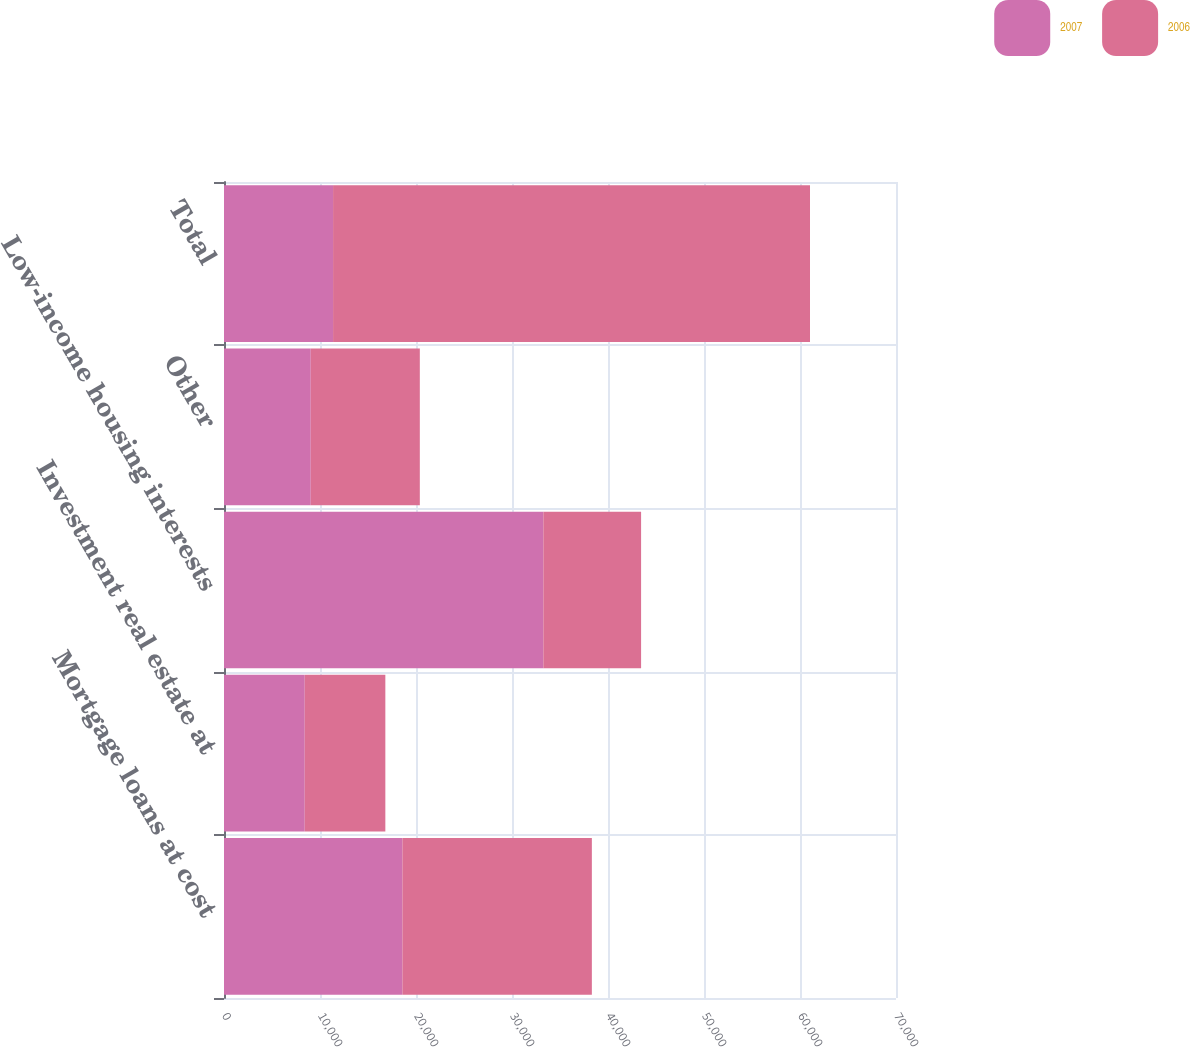Convert chart to OTSL. <chart><loc_0><loc_0><loc_500><loc_500><stacked_bar_chart><ecel><fcel>Mortgage loans at cost<fcel>Investment real estate at<fcel>Low-income housing interests<fcel>Other<fcel>Total<nl><fcel>2007<fcel>18580<fcel>8411<fcel>33262<fcel>9037<fcel>11361<nl><fcel>2006<fcel>19739<fcel>8396<fcel>10185<fcel>11361<fcel>49681<nl></chart> 